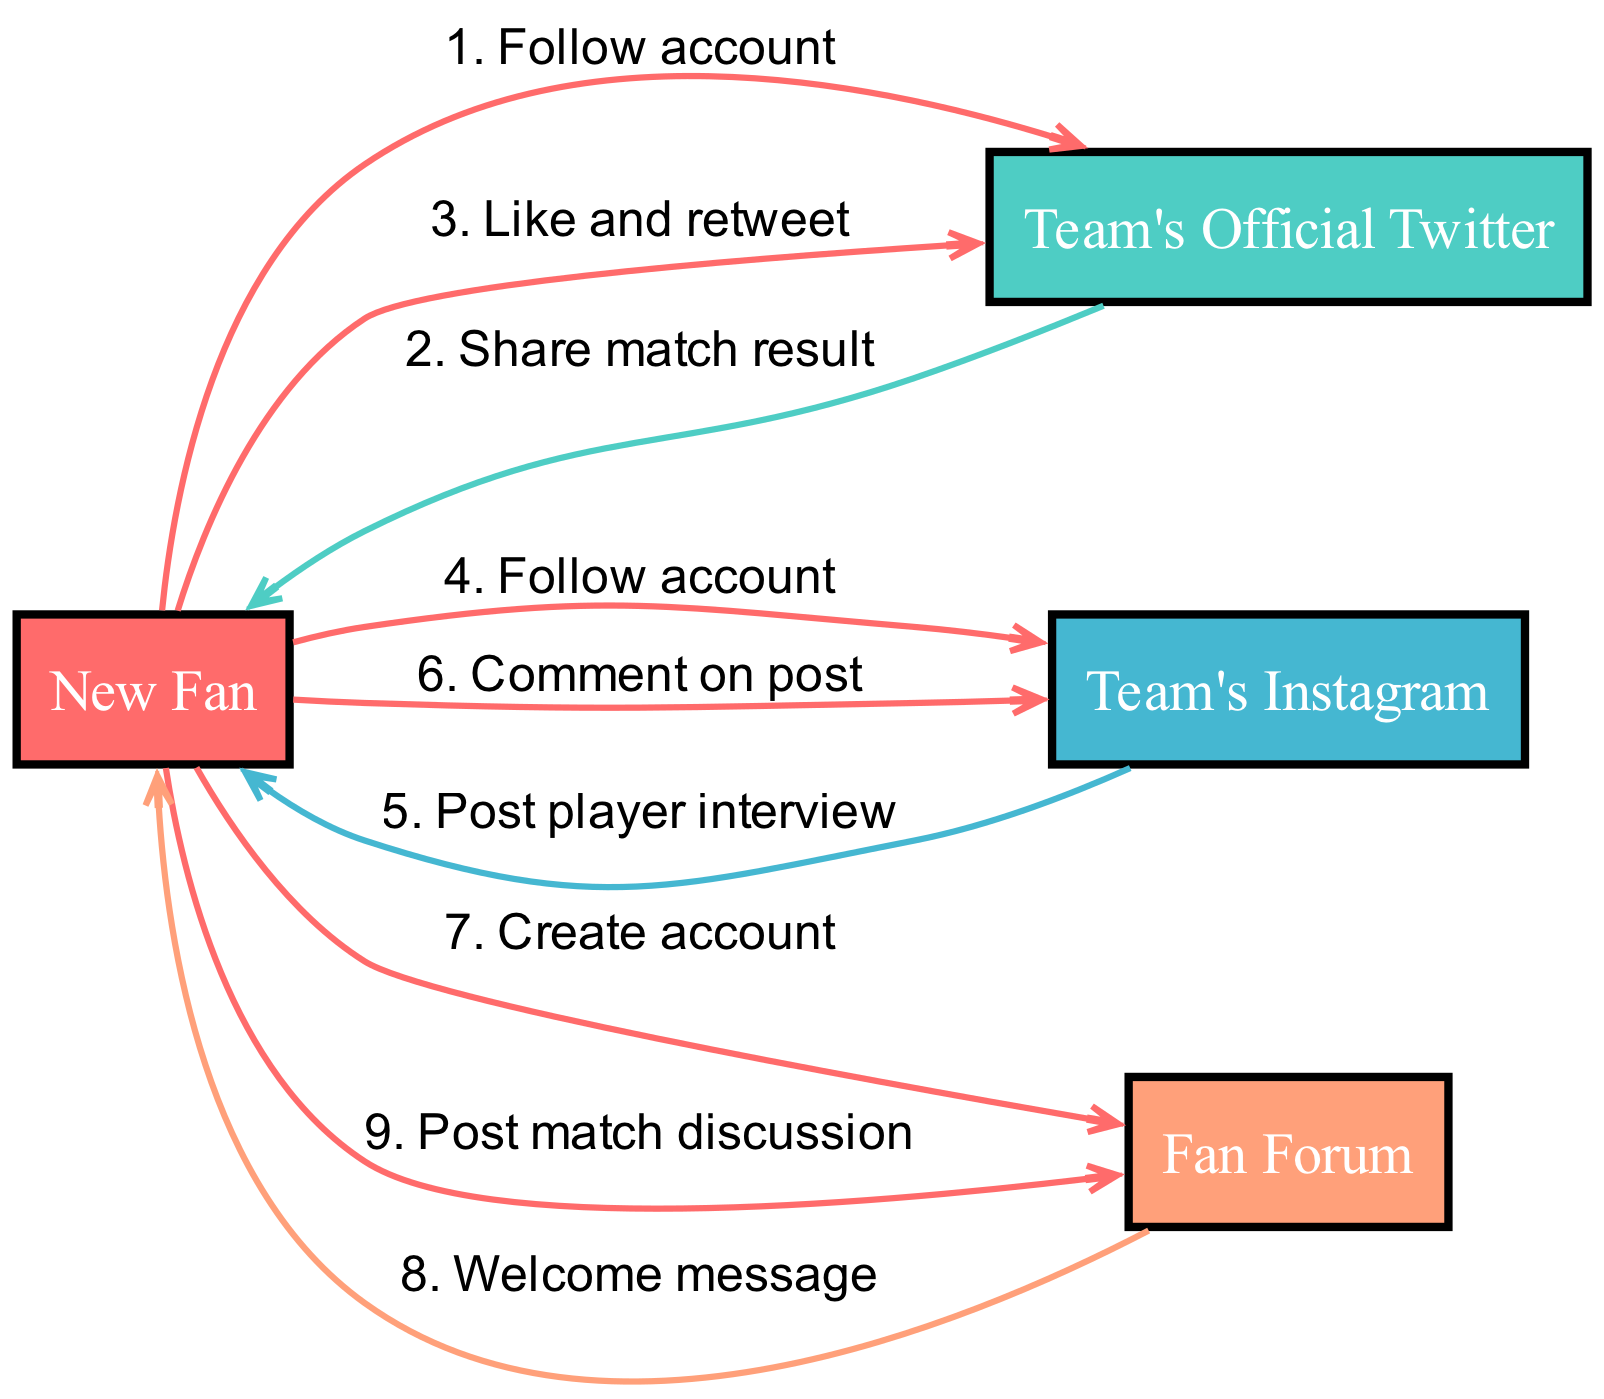What are the actors involved in the sequence? The actors listed in the diagram include "New Fan", "Team's Official Twitter", "Team's Instagram", and "Fan Forum".
Answer: New Fan, Team's Official Twitter, Team's Instagram, Fan Forum How many interactions are depicted in the diagram? By counting the interactions presented, there are a total of 8 interactions between the actors.
Answer: 8 Which social media platform does the New Fan follow first? The first interaction listed shows the New Fan following the "Team's Official Twitter".
Answer: Team's Official Twitter What message does the Team's Instagram send to the New Fan? The interaction from "Team's Instagram" to "New Fan" showcases a message stating "Post player interview".
Answer: Post player interview What is the sequence of actions taken by the New Fan after joining the Fan Forum? After creating an account on the "Fan Forum", the New Fan receives a "Welcome message", followed by posting a "match discussion".
Answer: Create account, Welcome message, Post match discussion How does the New Fan engage with Team's Official Twitter? The New Fan first follows the account, then shares the match result and likes and retweets.
Answer: Follow account, Share match result, Like and retweet What is the last action of the New Fan in the sequence? The last recorded action from the New Fan in the interactions is "Post match discussion" on the Fan Forum.
Answer: Post match discussion Which platform sends a welcome message to the New Fan? The "Fan Forum" sends a welcome message after the New Fan creates an account.
Answer: Fan Forum 